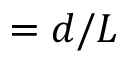Convert formula to latex. <formula><loc_0><loc_0><loc_500><loc_500>= d / L</formula> 